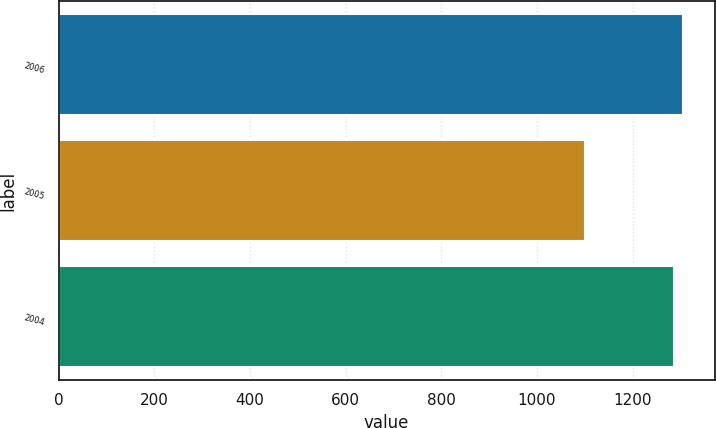Convert chart. <chart><loc_0><loc_0><loc_500><loc_500><bar_chart><fcel>2006<fcel>2005<fcel>2004<nl><fcel>1305.72<fcel>1099.7<fcel>1286.7<nl></chart> 